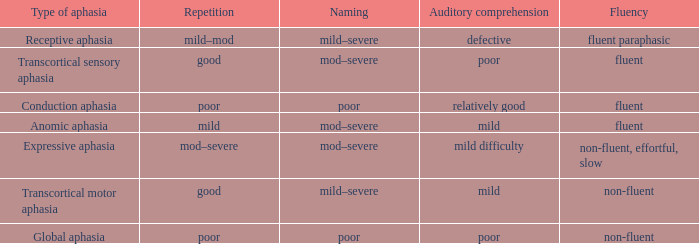Name the fluency for transcortical sensory aphasia Fluent. 